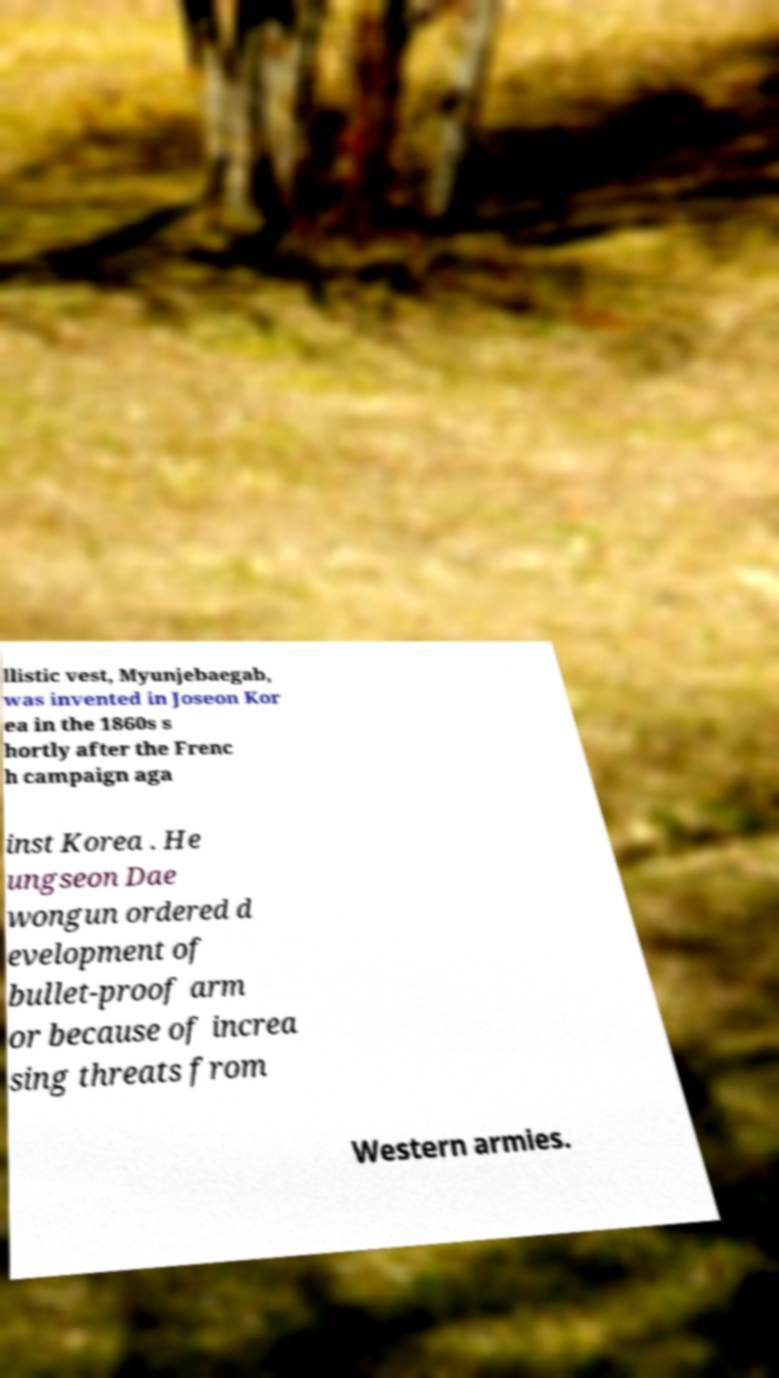What messages or text are displayed in this image? I need them in a readable, typed format. llistic vest, Myunjebaegab, was invented in Joseon Kor ea in the 1860s s hortly after the Frenc h campaign aga inst Korea . He ungseon Dae wongun ordered d evelopment of bullet-proof arm or because of increa sing threats from Western armies. 